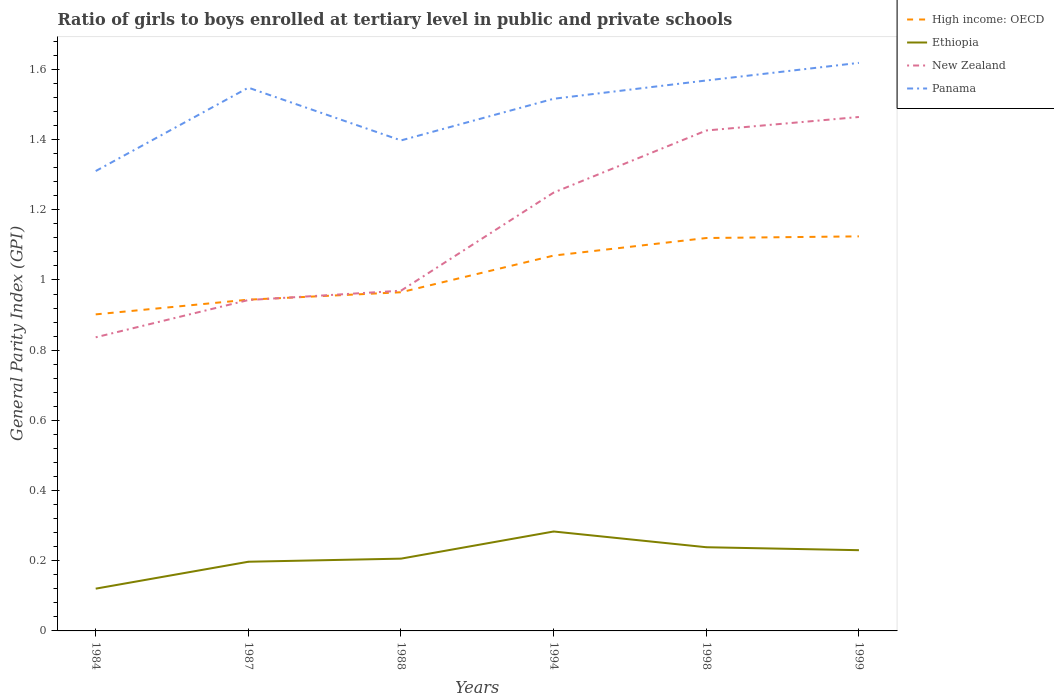How many different coloured lines are there?
Offer a very short reply. 4. Does the line corresponding to Ethiopia intersect with the line corresponding to Panama?
Offer a very short reply. No. Across all years, what is the maximum general parity index in High income: OECD?
Offer a terse response. 0.9. In which year was the general parity index in Ethiopia maximum?
Offer a terse response. 1984. What is the total general parity index in High income: OECD in the graph?
Your answer should be very brief. -0. What is the difference between the highest and the second highest general parity index in Panama?
Your response must be concise. 0.31. What is the difference between the highest and the lowest general parity index in Panama?
Offer a terse response. 4. Is the general parity index in New Zealand strictly greater than the general parity index in Panama over the years?
Provide a succinct answer. Yes. How many years are there in the graph?
Your response must be concise. 6. What is the difference between two consecutive major ticks on the Y-axis?
Provide a short and direct response. 0.2. Are the values on the major ticks of Y-axis written in scientific E-notation?
Keep it short and to the point. No. Does the graph contain any zero values?
Offer a terse response. No. How are the legend labels stacked?
Keep it short and to the point. Vertical. What is the title of the graph?
Your answer should be compact. Ratio of girls to boys enrolled at tertiary level in public and private schools. Does "Austria" appear as one of the legend labels in the graph?
Offer a very short reply. No. What is the label or title of the X-axis?
Offer a terse response. Years. What is the label or title of the Y-axis?
Offer a terse response. General Parity Index (GPI). What is the General Parity Index (GPI) of High income: OECD in 1984?
Provide a short and direct response. 0.9. What is the General Parity Index (GPI) of Ethiopia in 1984?
Your answer should be compact. 0.12. What is the General Parity Index (GPI) of New Zealand in 1984?
Offer a terse response. 0.84. What is the General Parity Index (GPI) in Panama in 1984?
Provide a short and direct response. 1.31. What is the General Parity Index (GPI) of High income: OECD in 1987?
Ensure brevity in your answer.  0.94. What is the General Parity Index (GPI) of Ethiopia in 1987?
Your response must be concise. 0.2. What is the General Parity Index (GPI) of New Zealand in 1987?
Give a very brief answer. 0.94. What is the General Parity Index (GPI) of Panama in 1987?
Give a very brief answer. 1.55. What is the General Parity Index (GPI) of High income: OECD in 1988?
Your response must be concise. 0.97. What is the General Parity Index (GPI) of Ethiopia in 1988?
Provide a succinct answer. 0.21. What is the General Parity Index (GPI) of New Zealand in 1988?
Your response must be concise. 0.97. What is the General Parity Index (GPI) in Panama in 1988?
Keep it short and to the point. 1.4. What is the General Parity Index (GPI) of High income: OECD in 1994?
Give a very brief answer. 1.07. What is the General Parity Index (GPI) in Ethiopia in 1994?
Your response must be concise. 0.28. What is the General Parity Index (GPI) of New Zealand in 1994?
Your answer should be compact. 1.25. What is the General Parity Index (GPI) of Panama in 1994?
Offer a very short reply. 1.52. What is the General Parity Index (GPI) in High income: OECD in 1998?
Offer a very short reply. 1.12. What is the General Parity Index (GPI) of Ethiopia in 1998?
Ensure brevity in your answer.  0.24. What is the General Parity Index (GPI) of New Zealand in 1998?
Your answer should be very brief. 1.43. What is the General Parity Index (GPI) in Panama in 1998?
Offer a terse response. 1.57. What is the General Parity Index (GPI) in High income: OECD in 1999?
Offer a very short reply. 1.12. What is the General Parity Index (GPI) of Ethiopia in 1999?
Give a very brief answer. 0.23. What is the General Parity Index (GPI) of New Zealand in 1999?
Give a very brief answer. 1.46. What is the General Parity Index (GPI) of Panama in 1999?
Your response must be concise. 1.62. Across all years, what is the maximum General Parity Index (GPI) of High income: OECD?
Your answer should be very brief. 1.12. Across all years, what is the maximum General Parity Index (GPI) of Ethiopia?
Your answer should be very brief. 0.28. Across all years, what is the maximum General Parity Index (GPI) in New Zealand?
Provide a succinct answer. 1.46. Across all years, what is the maximum General Parity Index (GPI) in Panama?
Your answer should be compact. 1.62. Across all years, what is the minimum General Parity Index (GPI) in High income: OECD?
Give a very brief answer. 0.9. Across all years, what is the minimum General Parity Index (GPI) of Ethiopia?
Ensure brevity in your answer.  0.12. Across all years, what is the minimum General Parity Index (GPI) in New Zealand?
Offer a very short reply. 0.84. Across all years, what is the minimum General Parity Index (GPI) of Panama?
Your answer should be compact. 1.31. What is the total General Parity Index (GPI) in High income: OECD in the graph?
Your answer should be very brief. 6.12. What is the total General Parity Index (GPI) in Ethiopia in the graph?
Your answer should be very brief. 1.28. What is the total General Parity Index (GPI) in New Zealand in the graph?
Provide a short and direct response. 6.89. What is the total General Parity Index (GPI) of Panama in the graph?
Offer a terse response. 8.96. What is the difference between the General Parity Index (GPI) in High income: OECD in 1984 and that in 1987?
Your answer should be very brief. -0.04. What is the difference between the General Parity Index (GPI) in Ethiopia in 1984 and that in 1987?
Make the answer very short. -0.08. What is the difference between the General Parity Index (GPI) of New Zealand in 1984 and that in 1987?
Your response must be concise. -0.11. What is the difference between the General Parity Index (GPI) in Panama in 1984 and that in 1987?
Your answer should be compact. -0.24. What is the difference between the General Parity Index (GPI) in High income: OECD in 1984 and that in 1988?
Your answer should be very brief. -0.06. What is the difference between the General Parity Index (GPI) of Ethiopia in 1984 and that in 1988?
Keep it short and to the point. -0.09. What is the difference between the General Parity Index (GPI) in New Zealand in 1984 and that in 1988?
Keep it short and to the point. -0.13. What is the difference between the General Parity Index (GPI) in Panama in 1984 and that in 1988?
Make the answer very short. -0.09. What is the difference between the General Parity Index (GPI) of High income: OECD in 1984 and that in 1994?
Provide a succinct answer. -0.17. What is the difference between the General Parity Index (GPI) in Ethiopia in 1984 and that in 1994?
Provide a succinct answer. -0.16. What is the difference between the General Parity Index (GPI) of New Zealand in 1984 and that in 1994?
Ensure brevity in your answer.  -0.41. What is the difference between the General Parity Index (GPI) of Panama in 1984 and that in 1994?
Offer a very short reply. -0.21. What is the difference between the General Parity Index (GPI) of High income: OECD in 1984 and that in 1998?
Provide a short and direct response. -0.22. What is the difference between the General Parity Index (GPI) in Ethiopia in 1984 and that in 1998?
Your response must be concise. -0.12. What is the difference between the General Parity Index (GPI) of New Zealand in 1984 and that in 1998?
Give a very brief answer. -0.59. What is the difference between the General Parity Index (GPI) in Panama in 1984 and that in 1998?
Provide a succinct answer. -0.26. What is the difference between the General Parity Index (GPI) of High income: OECD in 1984 and that in 1999?
Your answer should be very brief. -0.22. What is the difference between the General Parity Index (GPI) of Ethiopia in 1984 and that in 1999?
Make the answer very short. -0.11. What is the difference between the General Parity Index (GPI) of New Zealand in 1984 and that in 1999?
Your response must be concise. -0.63. What is the difference between the General Parity Index (GPI) of Panama in 1984 and that in 1999?
Offer a terse response. -0.31. What is the difference between the General Parity Index (GPI) of High income: OECD in 1987 and that in 1988?
Your response must be concise. -0.02. What is the difference between the General Parity Index (GPI) in Ethiopia in 1987 and that in 1988?
Offer a very short reply. -0.01. What is the difference between the General Parity Index (GPI) of New Zealand in 1987 and that in 1988?
Your answer should be compact. -0.03. What is the difference between the General Parity Index (GPI) in Panama in 1987 and that in 1988?
Your response must be concise. 0.15. What is the difference between the General Parity Index (GPI) of High income: OECD in 1987 and that in 1994?
Your answer should be very brief. -0.13. What is the difference between the General Parity Index (GPI) of Ethiopia in 1987 and that in 1994?
Keep it short and to the point. -0.09. What is the difference between the General Parity Index (GPI) in New Zealand in 1987 and that in 1994?
Your answer should be very brief. -0.31. What is the difference between the General Parity Index (GPI) in Panama in 1987 and that in 1994?
Offer a terse response. 0.03. What is the difference between the General Parity Index (GPI) in High income: OECD in 1987 and that in 1998?
Make the answer very short. -0.18. What is the difference between the General Parity Index (GPI) in Ethiopia in 1987 and that in 1998?
Offer a very short reply. -0.04. What is the difference between the General Parity Index (GPI) of New Zealand in 1987 and that in 1998?
Offer a terse response. -0.48. What is the difference between the General Parity Index (GPI) of Panama in 1987 and that in 1998?
Offer a very short reply. -0.02. What is the difference between the General Parity Index (GPI) of High income: OECD in 1987 and that in 1999?
Your answer should be compact. -0.18. What is the difference between the General Parity Index (GPI) of Ethiopia in 1987 and that in 1999?
Ensure brevity in your answer.  -0.03. What is the difference between the General Parity Index (GPI) in New Zealand in 1987 and that in 1999?
Give a very brief answer. -0.52. What is the difference between the General Parity Index (GPI) in Panama in 1987 and that in 1999?
Ensure brevity in your answer.  -0.07. What is the difference between the General Parity Index (GPI) of High income: OECD in 1988 and that in 1994?
Your answer should be compact. -0.1. What is the difference between the General Parity Index (GPI) in Ethiopia in 1988 and that in 1994?
Provide a short and direct response. -0.08. What is the difference between the General Parity Index (GPI) of New Zealand in 1988 and that in 1994?
Your response must be concise. -0.28. What is the difference between the General Parity Index (GPI) of Panama in 1988 and that in 1994?
Give a very brief answer. -0.12. What is the difference between the General Parity Index (GPI) in High income: OECD in 1988 and that in 1998?
Ensure brevity in your answer.  -0.15. What is the difference between the General Parity Index (GPI) in Ethiopia in 1988 and that in 1998?
Provide a succinct answer. -0.03. What is the difference between the General Parity Index (GPI) of New Zealand in 1988 and that in 1998?
Provide a short and direct response. -0.46. What is the difference between the General Parity Index (GPI) of Panama in 1988 and that in 1998?
Your answer should be very brief. -0.17. What is the difference between the General Parity Index (GPI) of High income: OECD in 1988 and that in 1999?
Provide a short and direct response. -0.16. What is the difference between the General Parity Index (GPI) of Ethiopia in 1988 and that in 1999?
Your answer should be compact. -0.02. What is the difference between the General Parity Index (GPI) of New Zealand in 1988 and that in 1999?
Provide a short and direct response. -0.49. What is the difference between the General Parity Index (GPI) in Panama in 1988 and that in 1999?
Make the answer very short. -0.22. What is the difference between the General Parity Index (GPI) in High income: OECD in 1994 and that in 1998?
Make the answer very short. -0.05. What is the difference between the General Parity Index (GPI) in Ethiopia in 1994 and that in 1998?
Offer a very short reply. 0.04. What is the difference between the General Parity Index (GPI) of New Zealand in 1994 and that in 1998?
Offer a very short reply. -0.18. What is the difference between the General Parity Index (GPI) in Panama in 1994 and that in 1998?
Make the answer very short. -0.05. What is the difference between the General Parity Index (GPI) in High income: OECD in 1994 and that in 1999?
Your response must be concise. -0.05. What is the difference between the General Parity Index (GPI) of Ethiopia in 1994 and that in 1999?
Your answer should be very brief. 0.05. What is the difference between the General Parity Index (GPI) in New Zealand in 1994 and that in 1999?
Provide a short and direct response. -0.22. What is the difference between the General Parity Index (GPI) in Panama in 1994 and that in 1999?
Provide a succinct answer. -0.1. What is the difference between the General Parity Index (GPI) in High income: OECD in 1998 and that in 1999?
Give a very brief answer. -0. What is the difference between the General Parity Index (GPI) of Ethiopia in 1998 and that in 1999?
Make the answer very short. 0.01. What is the difference between the General Parity Index (GPI) in New Zealand in 1998 and that in 1999?
Your response must be concise. -0.04. What is the difference between the General Parity Index (GPI) of Panama in 1998 and that in 1999?
Offer a very short reply. -0.05. What is the difference between the General Parity Index (GPI) in High income: OECD in 1984 and the General Parity Index (GPI) in Ethiopia in 1987?
Your answer should be compact. 0.7. What is the difference between the General Parity Index (GPI) in High income: OECD in 1984 and the General Parity Index (GPI) in New Zealand in 1987?
Your answer should be compact. -0.04. What is the difference between the General Parity Index (GPI) of High income: OECD in 1984 and the General Parity Index (GPI) of Panama in 1987?
Provide a succinct answer. -0.65. What is the difference between the General Parity Index (GPI) of Ethiopia in 1984 and the General Parity Index (GPI) of New Zealand in 1987?
Keep it short and to the point. -0.82. What is the difference between the General Parity Index (GPI) of Ethiopia in 1984 and the General Parity Index (GPI) of Panama in 1987?
Give a very brief answer. -1.43. What is the difference between the General Parity Index (GPI) in New Zealand in 1984 and the General Parity Index (GPI) in Panama in 1987?
Your response must be concise. -0.71. What is the difference between the General Parity Index (GPI) in High income: OECD in 1984 and the General Parity Index (GPI) in Ethiopia in 1988?
Your answer should be very brief. 0.7. What is the difference between the General Parity Index (GPI) in High income: OECD in 1984 and the General Parity Index (GPI) in New Zealand in 1988?
Your response must be concise. -0.07. What is the difference between the General Parity Index (GPI) in High income: OECD in 1984 and the General Parity Index (GPI) in Panama in 1988?
Keep it short and to the point. -0.5. What is the difference between the General Parity Index (GPI) in Ethiopia in 1984 and the General Parity Index (GPI) in New Zealand in 1988?
Keep it short and to the point. -0.85. What is the difference between the General Parity Index (GPI) in Ethiopia in 1984 and the General Parity Index (GPI) in Panama in 1988?
Make the answer very short. -1.28. What is the difference between the General Parity Index (GPI) in New Zealand in 1984 and the General Parity Index (GPI) in Panama in 1988?
Your answer should be very brief. -0.56. What is the difference between the General Parity Index (GPI) of High income: OECD in 1984 and the General Parity Index (GPI) of Ethiopia in 1994?
Your answer should be compact. 0.62. What is the difference between the General Parity Index (GPI) in High income: OECD in 1984 and the General Parity Index (GPI) in New Zealand in 1994?
Give a very brief answer. -0.35. What is the difference between the General Parity Index (GPI) of High income: OECD in 1984 and the General Parity Index (GPI) of Panama in 1994?
Your response must be concise. -0.61. What is the difference between the General Parity Index (GPI) of Ethiopia in 1984 and the General Parity Index (GPI) of New Zealand in 1994?
Your answer should be very brief. -1.13. What is the difference between the General Parity Index (GPI) in Ethiopia in 1984 and the General Parity Index (GPI) in Panama in 1994?
Offer a terse response. -1.4. What is the difference between the General Parity Index (GPI) in New Zealand in 1984 and the General Parity Index (GPI) in Panama in 1994?
Provide a short and direct response. -0.68. What is the difference between the General Parity Index (GPI) of High income: OECD in 1984 and the General Parity Index (GPI) of Ethiopia in 1998?
Give a very brief answer. 0.66. What is the difference between the General Parity Index (GPI) of High income: OECD in 1984 and the General Parity Index (GPI) of New Zealand in 1998?
Your answer should be compact. -0.52. What is the difference between the General Parity Index (GPI) in High income: OECD in 1984 and the General Parity Index (GPI) in Panama in 1998?
Offer a very short reply. -0.67. What is the difference between the General Parity Index (GPI) in Ethiopia in 1984 and the General Parity Index (GPI) in New Zealand in 1998?
Make the answer very short. -1.31. What is the difference between the General Parity Index (GPI) in Ethiopia in 1984 and the General Parity Index (GPI) in Panama in 1998?
Your answer should be very brief. -1.45. What is the difference between the General Parity Index (GPI) in New Zealand in 1984 and the General Parity Index (GPI) in Panama in 1998?
Your response must be concise. -0.73. What is the difference between the General Parity Index (GPI) in High income: OECD in 1984 and the General Parity Index (GPI) in Ethiopia in 1999?
Give a very brief answer. 0.67. What is the difference between the General Parity Index (GPI) of High income: OECD in 1984 and the General Parity Index (GPI) of New Zealand in 1999?
Make the answer very short. -0.56. What is the difference between the General Parity Index (GPI) in High income: OECD in 1984 and the General Parity Index (GPI) in Panama in 1999?
Provide a short and direct response. -0.72. What is the difference between the General Parity Index (GPI) in Ethiopia in 1984 and the General Parity Index (GPI) in New Zealand in 1999?
Keep it short and to the point. -1.34. What is the difference between the General Parity Index (GPI) in Ethiopia in 1984 and the General Parity Index (GPI) in Panama in 1999?
Offer a very short reply. -1.5. What is the difference between the General Parity Index (GPI) in New Zealand in 1984 and the General Parity Index (GPI) in Panama in 1999?
Provide a succinct answer. -0.78. What is the difference between the General Parity Index (GPI) in High income: OECD in 1987 and the General Parity Index (GPI) in Ethiopia in 1988?
Keep it short and to the point. 0.74. What is the difference between the General Parity Index (GPI) in High income: OECD in 1987 and the General Parity Index (GPI) in New Zealand in 1988?
Offer a very short reply. -0.03. What is the difference between the General Parity Index (GPI) of High income: OECD in 1987 and the General Parity Index (GPI) of Panama in 1988?
Offer a terse response. -0.45. What is the difference between the General Parity Index (GPI) of Ethiopia in 1987 and the General Parity Index (GPI) of New Zealand in 1988?
Your answer should be compact. -0.77. What is the difference between the General Parity Index (GPI) in Ethiopia in 1987 and the General Parity Index (GPI) in Panama in 1988?
Your answer should be compact. -1.2. What is the difference between the General Parity Index (GPI) of New Zealand in 1987 and the General Parity Index (GPI) of Panama in 1988?
Give a very brief answer. -0.45. What is the difference between the General Parity Index (GPI) in High income: OECD in 1987 and the General Parity Index (GPI) in Ethiopia in 1994?
Your answer should be compact. 0.66. What is the difference between the General Parity Index (GPI) of High income: OECD in 1987 and the General Parity Index (GPI) of New Zealand in 1994?
Provide a short and direct response. -0.31. What is the difference between the General Parity Index (GPI) of High income: OECD in 1987 and the General Parity Index (GPI) of Panama in 1994?
Ensure brevity in your answer.  -0.57. What is the difference between the General Parity Index (GPI) in Ethiopia in 1987 and the General Parity Index (GPI) in New Zealand in 1994?
Your answer should be compact. -1.05. What is the difference between the General Parity Index (GPI) in Ethiopia in 1987 and the General Parity Index (GPI) in Panama in 1994?
Your answer should be very brief. -1.32. What is the difference between the General Parity Index (GPI) of New Zealand in 1987 and the General Parity Index (GPI) of Panama in 1994?
Give a very brief answer. -0.57. What is the difference between the General Parity Index (GPI) in High income: OECD in 1987 and the General Parity Index (GPI) in Ethiopia in 1998?
Offer a very short reply. 0.71. What is the difference between the General Parity Index (GPI) of High income: OECD in 1987 and the General Parity Index (GPI) of New Zealand in 1998?
Make the answer very short. -0.48. What is the difference between the General Parity Index (GPI) of High income: OECD in 1987 and the General Parity Index (GPI) of Panama in 1998?
Your answer should be very brief. -0.62. What is the difference between the General Parity Index (GPI) of Ethiopia in 1987 and the General Parity Index (GPI) of New Zealand in 1998?
Your response must be concise. -1.23. What is the difference between the General Parity Index (GPI) in Ethiopia in 1987 and the General Parity Index (GPI) in Panama in 1998?
Provide a succinct answer. -1.37. What is the difference between the General Parity Index (GPI) in New Zealand in 1987 and the General Parity Index (GPI) in Panama in 1998?
Your answer should be compact. -0.63. What is the difference between the General Parity Index (GPI) in High income: OECD in 1987 and the General Parity Index (GPI) in Ethiopia in 1999?
Offer a terse response. 0.71. What is the difference between the General Parity Index (GPI) in High income: OECD in 1987 and the General Parity Index (GPI) in New Zealand in 1999?
Ensure brevity in your answer.  -0.52. What is the difference between the General Parity Index (GPI) in High income: OECD in 1987 and the General Parity Index (GPI) in Panama in 1999?
Ensure brevity in your answer.  -0.67. What is the difference between the General Parity Index (GPI) in Ethiopia in 1987 and the General Parity Index (GPI) in New Zealand in 1999?
Provide a succinct answer. -1.27. What is the difference between the General Parity Index (GPI) of Ethiopia in 1987 and the General Parity Index (GPI) of Panama in 1999?
Provide a short and direct response. -1.42. What is the difference between the General Parity Index (GPI) in New Zealand in 1987 and the General Parity Index (GPI) in Panama in 1999?
Offer a very short reply. -0.68. What is the difference between the General Parity Index (GPI) in High income: OECD in 1988 and the General Parity Index (GPI) in Ethiopia in 1994?
Offer a very short reply. 0.68. What is the difference between the General Parity Index (GPI) in High income: OECD in 1988 and the General Parity Index (GPI) in New Zealand in 1994?
Your answer should be very brief. -0.28. What is the difference between the General Parity Index (GPI) in High income: OECD in 1988 and the General Parity Index (GPI) in Panama in 1994?
Give a very brief answer. -0.55. What is the difference between the General Parity Index (GPI) of Ethiopia in 1988 and the General Parity Index (GPI) of New Zealand in 1994?
Provide a short and direct response. -1.04. What is the difference between the General Parity Index (GPI) in Ethiopia in 1988 and the General Parity Index (GPI) in Panama in 1994?
Offer a terse response. -1.31. What is the difference between the General Parity Index (GPI) in New Zealand in 1988 and the General Parity Index (GPI) in Panama in 1994?
Offer a very short reply. -0.55. What is the difference between the General Parity Index (GPI) of High income: OECD in 1988 and the General Parity Index (GPI) of Ethiopia in 1998?
Offer a very short reply. 0.73. What is the difference between the General Parity Index (GPI) in High income: OECD in 1988 and the General Parity Index (GPI) in New Zealand in 1998?
Provide a succinct answer. -0.46. What is the difference between the General Parity Index (GPI) of High income: OECD in 1988 and the General Parity Index (GPI) of Panama in 1998?
Your answer should be very brief. -0.6. What is the difference between the General Parity Index (GPI) in Ethiopia in 1988 and the General Parity Index (GPI) in New Zealand in 1998?
Offer a very short reply. -1.22. What is the difference between the General Parity Index (GPI) of Ethiopia in 1988 and the General Parity Index (GPI) of Panama in 1998?
Offer a very short reply. -1.36. What is the difference between the General Parity Index (GPI) in New Zealand in 1988 and the General Parity Index (GPI) in Panama in 1998?
Your response must be concise. -0.6. What is the difference between the General Parity Index (GPI) of High income: OECD in 1988 and the General Parity Index (GPI) of Ethiopia in 1999?
Offer a very short reply. 0.73. What is the difference between the General Parity Index (GPI) in High income: OECD in 1988 and the General Parity Index (GPI) in New Zealand in 1999?
Offer a very short reply. -0.5. What is the difference between the General Parity Index (GPI) of High income: OECD in 1988 and the General Parity Index (GPI) of Panama in 1999?
Your answer should be compact. -0.65. What is the difference between the General Parity Index (GPI) of Ethiopia in 1988 and the General Parity Index (GPI) of New Zealand in 1999?
Offer a very short reply. -1.26. What is the difference between the General Parity Index (GPI) of Ethiopia in 1988 and the General Parity Index (GPI) of Panama in 1999?
Ensure brevity in your answer.  -1.41. What is the difference between the General Parity Index (GPI) of New Zealand in 1988 and the General Parity Index (GPI) of Panama in 1999?
Offer a very short reply. -0.65. What is the difference between the General Parity Index (GPI) in High income: OECD in 1994 and the General Parity Index (GPI) in Ethiopia in 1998?
Keep it short and to the point. 0.83. What is the difference between the General Parity Index (GPI) in High income: OECD in 1994 and the General Parity Index (GPI) in New Zealand in 1998?
Keep it short and to the point. -0.36. What is the difference between the General Parity Index (GPI) of High income: OECD in 1994 and the General Parity Index (GPI) of Panama in 1998?
Offer a very short reply. -0.5. What is the difference between the General Parity Index (GPI) in Ethiopia in 1994 and the General Parity Index (GPI) in New Zealand in 1998?
Your response must be concise. -1.14. What is the difference between the General Parity Index (GPI) of Ethiopia in 1994 and the General Parity Index (GPI) of Panama in 1998?
Your response must be concise. -1.29. What is the difference between the General Parity Index (GPI) in New Zealand in 1994 and the General Parity Index (GPI) in Panama in 1998?
Ensure brevity in your answer.  -0.32. What is the difference between the General Parity Index (GPI) of High income: OECD in 1994 and the General Parity Index (GPI) of Ethiopia in 1999?
Your answer should be compact. 0.84. What is the difference between the General Parity Index (GPI) in High income: OECD in 1994 and the General Parity Index (GPI) in New Zealand in 1999?
Your answer should be very brief. -0.39. What is the difference between the General Parity Index (GPI) in High income: OECD in 1994 and the General Parity Index (GPI) in Panama in 1999?
Provide a short and direct response. -0.55. What is the difference between the General Parity Index (GPI) in Ethiopia in 1994 and the General Parity Index (GPI) in New Zealand in 1999?
Offer a terse response. -1.18. What is the difference between the General Parity Index (GPI) in Ethiopia in 1994 and the General Parity Index (GPI) in Panama in 1999?
Offer a very short reply. -1.34. What is the difference between the General Parity Index (GPI) in New Zealand in 1994 and the General Parity Index (GPI) in Panama in 1999?
Offer a terse response. -0.37. What is the difference between the General Parity Index (GPI) in High income: OECD in 1998 and the General Parity Index (GPI) in Ethiopia in 1999?
Provide a short and direct response. 0.89. What is the difference between the General Parity Index (GPI) of High income: OECD in 1998 and the General Parity Index (GPI) of New Zealand in 1999?
Provide a short and direct response. -0.34. What is the difference between the General Parity Index (GPI) in High income: OECD in 1998 and the General Parity Index (GPI) in Panama in 1999?
Offer a terse response. -0.5. What is the difference between the General Parity Index (GPI) in Ethiopia in 1998 and the General Parity Index (GPI) in New Zealand in 1999?
Give a very brief answer. -1.23. What is the difference between the General Parity Index (GPI) of Ethiopia in 1998 and the General Parity Index (GPI) of Panama in 1999?
Your response must be concise. -1.38. What is the difference between the General Parity Index (GPI) of New Zealand in 1998 and the General Parity Index (GPI) of Panama in 1999?
Your response must be concise. -0.19. What is the average General Parity Index (GPI) of High income: OECD per year?
Provide a succinct answer. 1.02. What is the average General Parity Index (GPI) of Ethiopia per year?
Give a very brief answer. 0.21. What is the average General Parity Index (GPI) in New Zealand per year?
Offer a very short reply. 1.15. What is the average General Parity Index (GPI) of Panama per year?
Your response must be concise. 1.49. In the year 1984, what is the difference between the General Parity Index (GPI) of High income: OECD and General Parity Index (GPI) of Ethiopia?
Your answer should be compact. 0.78. In the year 1984, what is the difference between the General Parity Index (GPI) of High income: OECD and General Parity Index (GPI) of New Zealand?
Give a very brief answer. 0.07. In the year 1984, what is the difference between the General Parity Index (GPI) in High income: OECD and General Parity Index (GPI) in Panama?
Provide a succinct answer. -0.41. In the year 1984, what is the difference between the General Parity Index (GPI) of Ethiopia and General Parity Index (GPI) of New Zealand?
Give a very brief answer. -0.72. In the year 1984, what is the difference between the General Parity Index (GPI) in Ethiopia and General Parity Index (GPI) in Panama?
Offer a very short reply. -1.19. In the year 1984, what is the difference between the General Parity Index (GPI) in New Zealand and General Parity Index (GPI) in Panama?
Your answer should be very brief. -0.47. In the year 1987, what is the difference between the General Parity Index (GPI) in High income: OECD and General Parity Index (GPI) in Ethiopia?
Make the answer very short. 0.75. In the year 1987, what is the difference between the General Parity Index (GPI) of High income: OECD and General Parity Index (GPI) of New Zealand?
Offer a terse response. 0. In the year 1987, what is the difference between the General Parity Index (GPI) of High income: OECD and General Parity Index (GPI) of Panama?
Provide a short and direct response. -0.6. In the year 1987, what is the difference between the General Parity Index (GPI) of Ethiopia and General Parity Index (GPI) of New Zealand?
Offer a terse response. -0.75. In the year 1987, what is the difference between the General Parity Index (GPI) in Ethiopia and General Parity Index (GPI) in Panama?
Offer a terse response. -1.35. In the year 1987, what is the difference between the General Parity Index (GPI) of New Zealand and General Parity Index (GPI) of Panama?
Your response must be concise. -0.61. In the year 1988, what is the difference between the General Parity Index (GPI) in High income: OECD and General Parity Index (GPI) in Ethiopia?
Provide a short and direct response. 0.76. In the year 1988, what is the difference between the General Parity Index (GPI) of High income: OECD and General Parity Index (GPI) of New Zealand?
Your answer should be very brief. -0. In the year 1988, what is the difference between the General Parity Index (GPI) in High income: OECD and General Parity Index (GPI) in Panama?
Ensure brevity in your answer.  -0.43. In the year 1988, what is the difference between the General Parity Index (GPI) of Ethiopia and General Parity Index (GPI) of New Zealand?
Your answer should be compact. -0.76. In the year 1988, what is the difference between the General Parity Index (GPI) in Ethiopia and General Parity Index (GPI) in Panama?
Give a very brief answer. -1.19. In the year 1988, what is the difference between the General Parity Index (GPI) in New Zealand and General Parity Index (GPI) in Panama?
Provide a succinct answer. -0.43. In the year 1994, what is the difference between the General Parity Index (GPI) of High income: OECD and General Parity Index (GPI) of Ethiopia?
Offer a terse response. 0.79. In the year 1994, what is the difference between the General Parity Index (GPI) in High income: OECD and General Parity Index (GPI) in New Zealand?
Your answer should be compact. -0.18. In the year 1994, what is the difference between the General Parity Index (GPI) of High income: OECD and General Parity Index (GPI) of Panama?
Offer a very short reply. -0.45. In the year 1994, what is the difference between the General Parity Index (GPI) of Ethiopia and General Parity Index (GPI) of New Zealand?
Offer a very short reply. -0.97. In the year 1994, what is the difference between the General Parity Index (GPI) in Ethiopia and General Parity Index (GPI) in Panama?
Your answer should be very brief. -1.23. In the year 1994, what is the difference between the General Parity Index (GPI) of New Zealand and General Parity Index (GPI) of Panama?
Your answer should be compact. -0.27. In the year 1998, what is the difference between the General Parity Index (GPI) in High income: OECD and General Parity Index (GPI) in Ethiopia?
Offer a very short reply. 0.88. In the year 1998, what is the difference between the General Parity Index (GPI) in High income: OECD and General Parity Index (GPI) in New Zealand?
Provide a succinct answer. -0.31. In the year 1998, what is the difference between the General Parity Index (GPI) in High income: OECD and General Parity Index (GPI) in Panama?
Your answer should be very brief. -0.45. In the year 1998, what is the difference between the General Parity Index (GPI) in Ethiopia and General Parity Index (GPI) in New Zealand?
Your answer should be compact. -1.19. In the year 1998, what is the difference between the General Parity Index (GPI) in Ethiopia and General Parity Index (GPI) in Panama?
Offer a terse response. -1.33. In the year 1998, what is the difference between the General Parity Index (GPI) of New Zealand and General Parity Index (GPI) of Panama?
Give a very brief answer. -0.14. In the year 1999, what is the difference between the General Parity Index (GPI) in High income: OECD and General Parity Index (GPI) in Ethiopia?
Give a very brief answer. 0.89. In the year 1999, what is the difference between the General Parity Index (GPI) in High income: OECD and General Parity Index (GPI) in New Zealand?
Offer a very short reply. -0.34. In the year 1999, what is the difference between the General Parity Index (GPI) of High income: OECD and General Parity Index (GPI) of Panama?
Give a very brief answer. -0.49. In the year 1999, what is the difference between the General Parity Index (GPI) in Ethiopia and General Parity Index (GPI) in New Zealand?
Offer a very short reply. -1.23. In the year 1999, what is the difference between the General Parity Index (GPI) of Ethiopia and General Parity Index (GPI) of Panama?
Keep it short and to the point. -1.39. In the year 1999, what is the difference between the General Parity Index (GPI) of New Zealand and General Parity Index (GPI) of Panama?
Offer a very short reply. -0.15. What is the ratio of the General Parity Index (GPI) in High income: OECD in 1984 to that in 1987?
Your response must be concise. 0.96. What is the ratio of the General Parity Index (GPI) in Ethiopia in 1984 to that in 1987?
Keep it short and to the point. 0.61. What is the ratio of the General Parity Index (GPI) in New Zealand in 1984 to that in 1987?
Offer a very short reply. 0.89. What is the ratio of the General Parity Index (GPI) of Panama in 1984 to that in 1987?
Make the answer very short. 0.85. What is the ratio of the General Parity Index (GPI) in High income: OECD in 1984 to that in 1988?
Give a very brief answer. 0.93. What is the ratio of the General Parity Index (GPI) in Ethiopia in 1984 to that in 1988?
Keep it short and to the point. 0.58. What is the ratio of the General Parity Index (GPI) in New Zealand in 1984 to that in 1988?
Offer a very short reply. 0.86. What is the ratio of the General Parity Index (GPI) in Panama in 1984 to that in 1988?
Your response must be concise. 0.94. What is the ratio of the General Parity Index (GPI) in High income: OECD in 1984 to that in 1994?
Your answer should be very brief. 0.84. What is the ratio of the General Parity Index (GPI) in Ethiopia in 1984 to that in 1994?
Make the answer very short. 0.43. What is the ratio of the General Parity Index (GPI) in New Zealand in 1984 to that in 1994?
Provide a succinct answer. 0.67. What is the ratio of the General Parity Index (GPI) of Panama in 1984 to that in 1994?
Ensure brevity in your answer.  0.86. What is the ratio of the General Parity Index (GPI) in High income: OECD in 1984 to that in 1998?
Keep it short and to the point. 0.81. What is the ratio of the General Parity Index (GPI) of Ethiopia in 1984 to that in 1998?
Provide a succinct answer. 0.51. What is the ratio of the General Parity Index (GPI) of New Zealand in 1984 to that in 1998?
Offer a terse response. 0.59. What is the ratio of the General Parity Index (GPI) of Panama in 1984 to that in 1998?
Keep it short and to the point. 0.84. What is the ratio of the General Parity Index (GPI) of High income: OECD in 1984 to that in 1999?
Ensure brevity in your answer.  0.8. What is the ratio of the General Parity Index (GPI) of Ethiopia in 1984 to that in 1999?
Offer a very short reply. 0.52. What is the ratio of the General Parity Index (GPI) in New Zealand in 1984 to that in 1999?
Your answer should be compact. 0.57. What is the ratio of the General Parity Index (GPI) in Panama in 1984 to that in 1999?
Offer a terse response. 0.81. What is the ratio of the General Parity Index (GPI) of High income: OECD in 1987 to that in 1988?
Keep it short and to the point. 0.98. What is the ratio of the General Parity Index (GPI) of Ethiopia in 1987 to that in 1988?
Offer a very short reply. 0.96. What is the ratio of the General Parity Index (GPI) in New Zealand in 1987 to that in 1988?
Your response must be concise. 0.97. What is the ratio of the General Parity Index (GPI) in Panama in 1987 to that in 1988?
Give a very brief answer. 1.11. What is the ratio of the General Parity Index (GPI) of High income: OECD in 1987 to that in 1994?
Offer a very short reply. 0.88. What is the ratio of the General Parity Index (GPI) of Ethiopia in 1987 to that in 1994?
Give a very brief answer. 0.7. What is the ratio of the General Parity Index (GPI) in New Zealand in 1987 to that in 1994?
Provide a succinct answer. 0.75. What is the ratio of the General Parity Index (GPI) of Panama in 1987 to that in 1994?
Your answer should be compact. 1.02. What is the ratio of the General Parity Index (GPI) of High income: OECD in 1987 to that in 1998?
Your response must be concise. 0.84. What is the ratio of the General Parity Index (GPI) of Ethiopia in 1987 to that in 1998?
Your answer should be very brief. 0.83. What is the ratio of the General Parity Index (GPI) of New Zealand in 1987 to that in 1998?
Your answer should be very brief. 0.66. What is the ratio of the General Parity Index (GPI) in High income: OECD in 1987 to that in 1999?
Your answer should be very brief. 0.84. What is the ratio of the General Parity Index (GPI) of Ethiopia in 1987 to that in 1999?
Your response must be concise. 0.86. What is the ratio of the General Parity Index (GPI) of New Zealand in 1987 to that in 1999?
Ensure brevity in your answer.  0.64. What is the ratio of the General Parity Index (GPI) of Panama in 1987 to that in 1999?
Give a very brief answer. 0.96. What is the ratio of the General Parity Index (GPI) in High income: OECD in 1988 to that in 1994?
Keep it short and to the point. 0.9. What is the ratio of the General Parity Index (GPI) in Ethiopia in 1988 to that in 1994?
Offer a terse response. 0.73. What is the ratio of the General Parity Index (GPI) of New Zealand in 1988 to that in 1994?
Offer a terse response. 0.78. What is the ratio of the General Parity Index (GPI) in Panama in 1988 to that in 1994?
Give a very brief answer. 0.92. What is the ratio of the General Parity Index (GPI) of High income: OECD in 1988 to that in 1998?
Ensure brevity in your answer.  0.86. What is the ratio of the General Parity Index (GPI) of Ethiopia in 1988 to that in 1998?
Give a very brief answer. 0.86. What is the ratio of the General Parity Index (GPI) in New Zealand in 1988 to that in 1998?
Offer a very short reply. 0.68. What is the ratio of the General Parity Index (GPI) in Panama in 1988 to that in 1998?
Offer a very short reply. 0.89. What is the ratio of the General Parity Index (GPI) in High income: OECD in 1988 to that in 1999?
Provide a succinct answer. 0.86. What is the ratio of the General Parity Index (GPI) of Ethiopia in 1988 to that in 1999?
Make the answer very short. 0.9. What is the ratio of the General Parity Index (GPI) in New Zealand in 1988 to that in 1999?
Your response must be concise. 0.66. What is the ratio of the General Parity Index (GPI) in Panama in 1988 to that in 1999?
Ensure brevity in your answer.  0.86. What is the ratio of the General Parity Index (GPI) of High income: OECD in 1994 to that in 1998?
Offer a terse response. 0.96. What is the ratio of the General Parity Index (GPI) of Ethiopia in 1994 to that in 1998?
Offer a terse response. 1.19. What is the ratio of the General Parity Index (GPI) in New Zealand in 1994 to that in 1998?
Make the answer very short. 0.88. What is the ratio of the General Parity Index (GPI) in Panama in 1994 to that in 1998?
Make the answer very short. 0.97. What is the ratio of the General Parity Index (GPI) of High income: OECD in 1994 to that in 1999?
Make the answer very short. 0.95. What is the ratio of the General Parity Index (GPI) in Ethiopia in 1994 to that in 1999?
Your answer should be compact. 1.23. What is the ratio of the General Parity Index (GPI) of New Zealand in 1994 to that in 1999?
Offer a terse response. 0.85. What is the ratio of the General Parity Index (GPI) in Panama in 1994 to that in 1999?
Offer a terse response. 0.94. What is the ratio of the General Parity Index (GPI) of High income: OECD in 1998 to that in 1999?
Provide a short and direct response. 1. What is the ratio of the General Parity Index (GPI) in Ethiopia in 1998 to that in 1999?
Offer a very short reply. 1.04. What is the ratio of the General Parity Index (GPI) in New Zealand in 1998 to that in 1999?
Provide a short and direct response. 0.97. What is the difference between the highest and the second highest General Parity Index (GPI) in High income: OECD?
Provide a succinct answer. 0. What is the difference between the highest and the second highest General Parity Index (GPI) of Ethiopia?
Your answer should be very brief. 0.04. What is the difference between the highest and the second highest General Parity Index (GPI) of New Zealand?
Offer a very short reply. 0.04. What is the difference between the highest and the second highest General Parity Index (GPI) of Panama?
Offer a terse response. 0.05. What is the difference between the highest and the lowest General Parity Index (GPI) in High income: OECD?
Your answer should be compact. 0.22. What is the difference between the highest and the lowest General Parity Index (GPI) of Ethiopia?
Ensure brevity in your answer.  0.16. What is the difference between the highest and the lowest General Parity Index (GPI) in New Zealand?
Provide a short and direct response. 0.63. What is the difference between the highest and the lowest General Parity Index (GPI) of Panama?
Your answer should be compact. 0.31. 